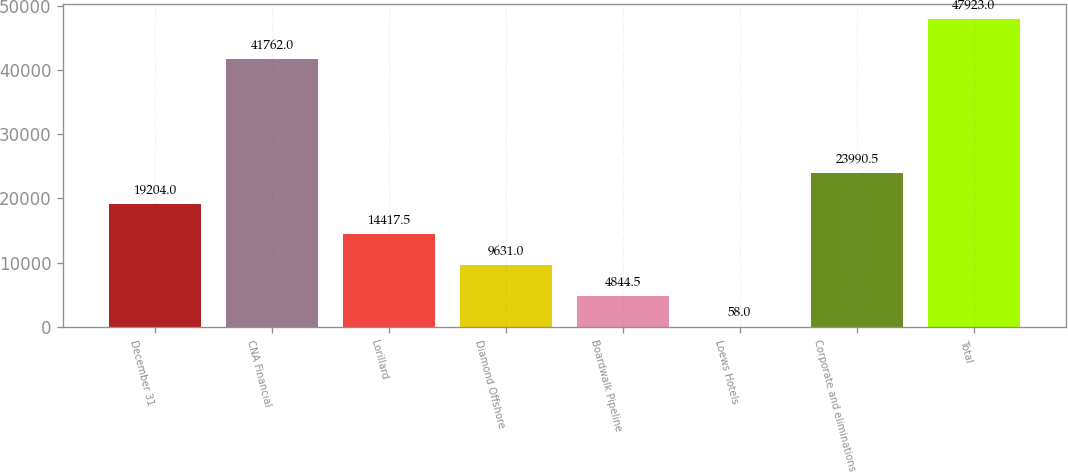<chart> <loc_0><loc_0><loc_500><loc_500><bar_chart><fcel>December 31<fcel>CNA Financial<fcel>Lorillard<fcel>Diamond Offshore<fcel>Boardwalk Pipeline<fcel>Loews Hotels<fcel>Corporate and eliminations<fcel>Total<nl><fcel>19204<fcel>41762<fcel>14417.5<fcel>9631<fcel>4844.5<fcel>58<fcel>23990.5<fcel>47923<nl></chart> 